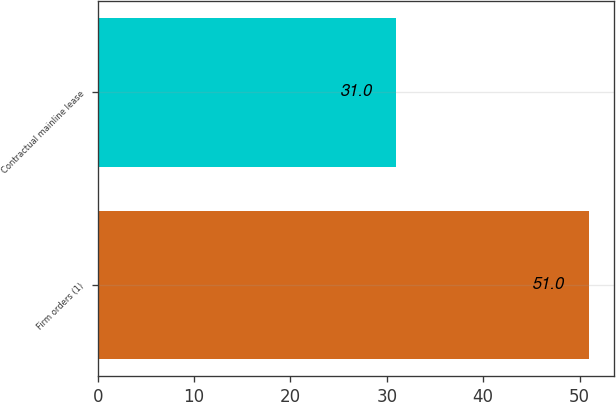Convert chart. <chart><loc_0><loc_0><loc_500><loc_500><bar_chart><fcel>Firm orders (1)<fcel>Contractual mainline lease<nl><fcel>51<fcel>31<nl></chart> 